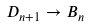Convert formula to latex. <formula><loc_0><loc_0><loc_500><loc_500>D _ { n + 1 } \to B _ { n }</formula> 